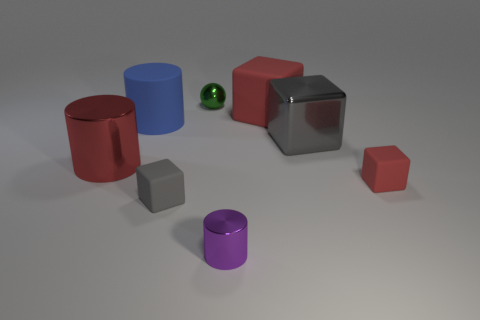Subtract all gray spheres. How many red blocks are left? 2 Subtract all large metal cubes. How many cubes are left? 3 Add 1 tiny green metal things. How many objects exist? 9 Subtract 1 cubes. How many cubes are left? 3 Subtract all balls. How many objects are left? 7 Subtract all yellow cylinders. Subtract all green cubes. How many cylinders are left? 3 Add 6 purple things. How many purple things are left? 7 Add 1 blue cylinders. How many blue cylinders exist? 2 Subtract 1 red cylinders. How many objects are left? 7 Subtract all small green things. Subtract all large metallic blocks. How many objects are left? 6 